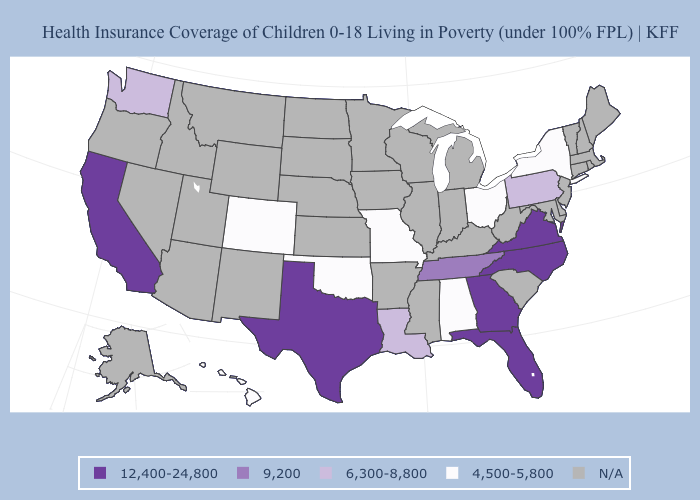Among the states that border Oklahoma , does Texas have the highest value?
Answer briefly. Yes. Which states have the lowest value in the South?
Quick response, please. Alabama, Oklahoma. Name the states that have a value in the range 9,200?
Short answer required. Tennessee. Does the map have missing data?
Be succinct. Yes. How many symbols are there in the legend?
Concise answer only. 5. Does North Carolina have the lowest value in the USA?
Give a very brief answer. No. Does the map have missing data?
Concise answer only. Yes. What is the highest value in the USA?
Answer briefly. 12,400-24,800. Does the first symbol in the legend represent the smallest category?
Short answer required. No. Name the states that have a value in the range 12,400-24,800?
Be succinct. California, Florida, Georgia, North Carolina, Texas, Virginia. What is the value of Massachusetts?
Answer briefly. N/A. Name the states that have a value in the range 4,500-5,800?
Concise answer only. Alabama, Colorado, Hawaii, Missouri, New York, Ohio, Oklahoma. Name the states that have a value in the range 9,200?
Be succinct. Tennessee. What is the value of Utah?
Write a very short answer. N/A. 